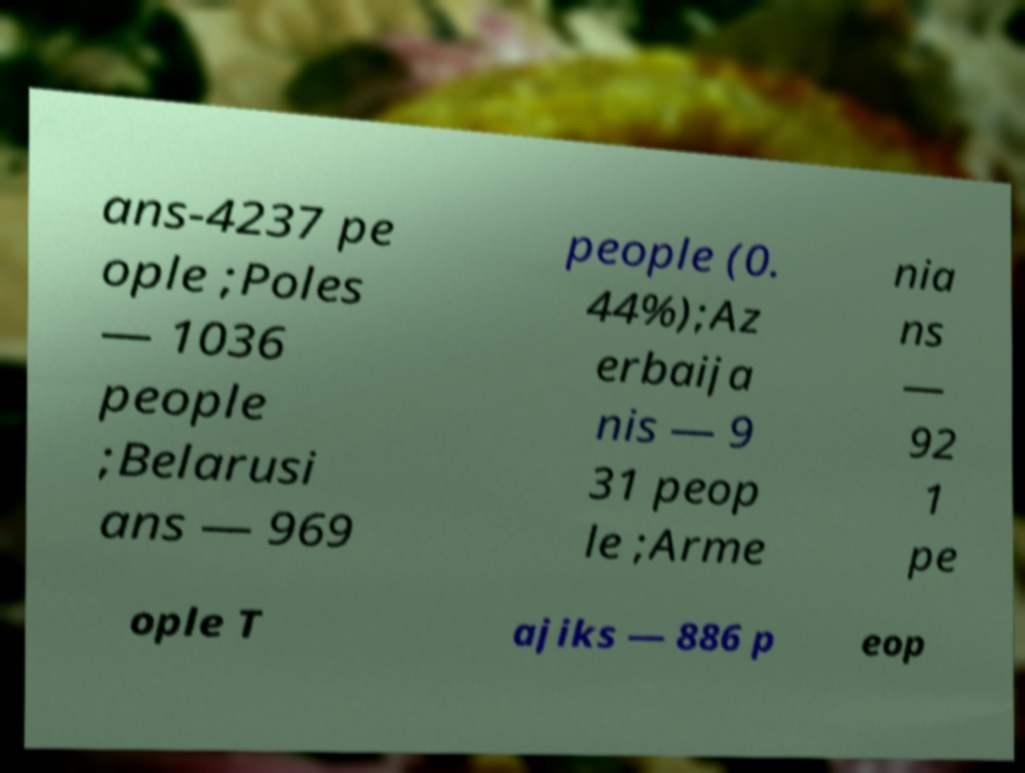There's text embedded in this image that I need extracted. Can you transcribe it verbatim? ans-4237 pe ople ;Poles — 1036 people ;Belarusi ans — 969 people (0. 44%);Az erbaija nis — 9 31 peop le ;Arme nia ns — 92 1 pe ople T ajiks — 886 p eop 